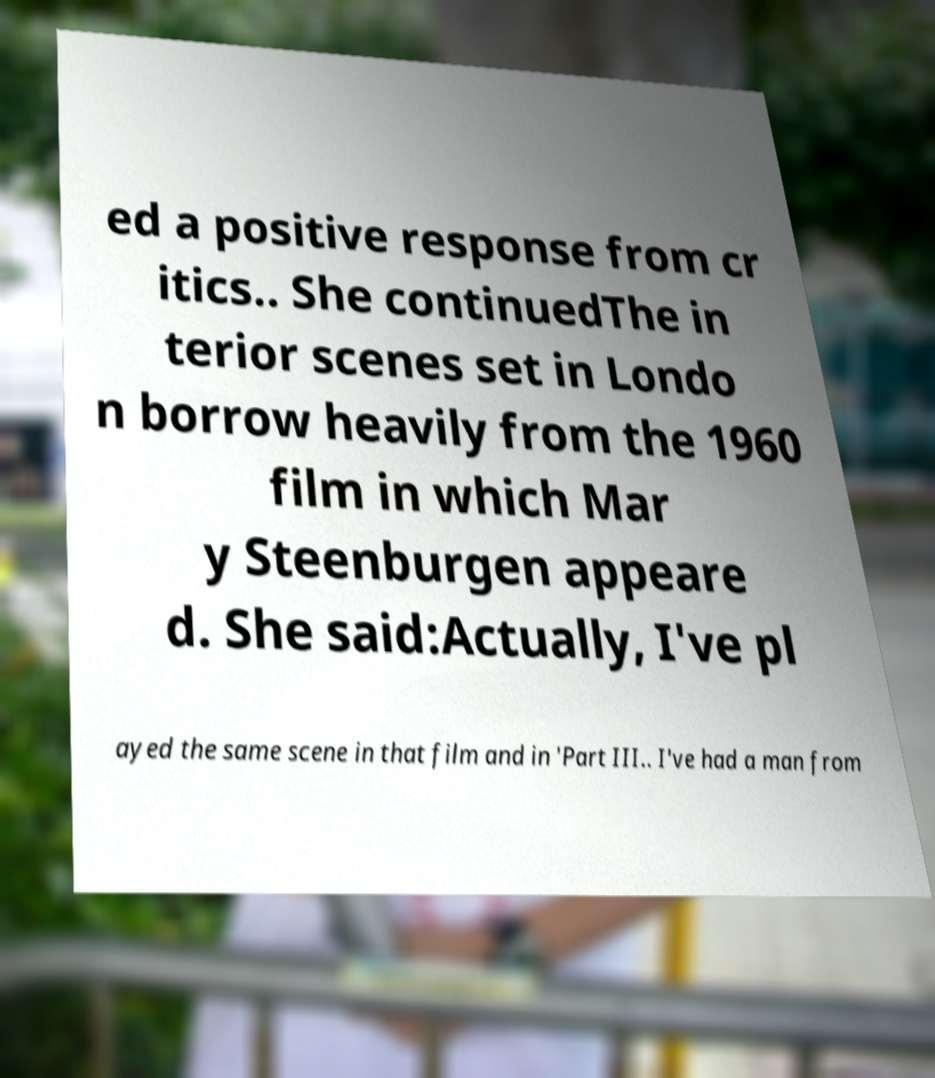Could you assist in decoding the text presented in this image and type it out clearly? ed a positive response from cr itics.. She continuedThe in terior scenes set in Londo n borrow heavily from the 1960 film in which Mar y Steenburgen appeare d. She said:Actually, I've pl ayed the same scene in that film and in 'Part III.. I've had a man from 